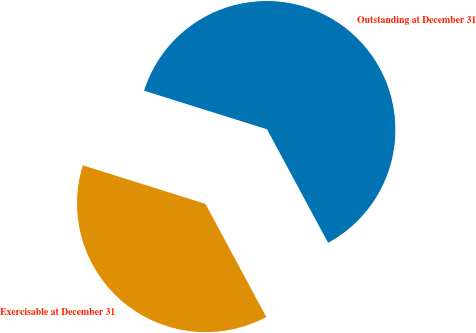Convert chart. <chart><loc_0><loc_0><loc_500><loc_500><pie_chart><fcel>Outstanding at December 31<fcel>Exercisable at December 31<nl><fcel>62.3%<fcel>37.7%<nl></chart> 